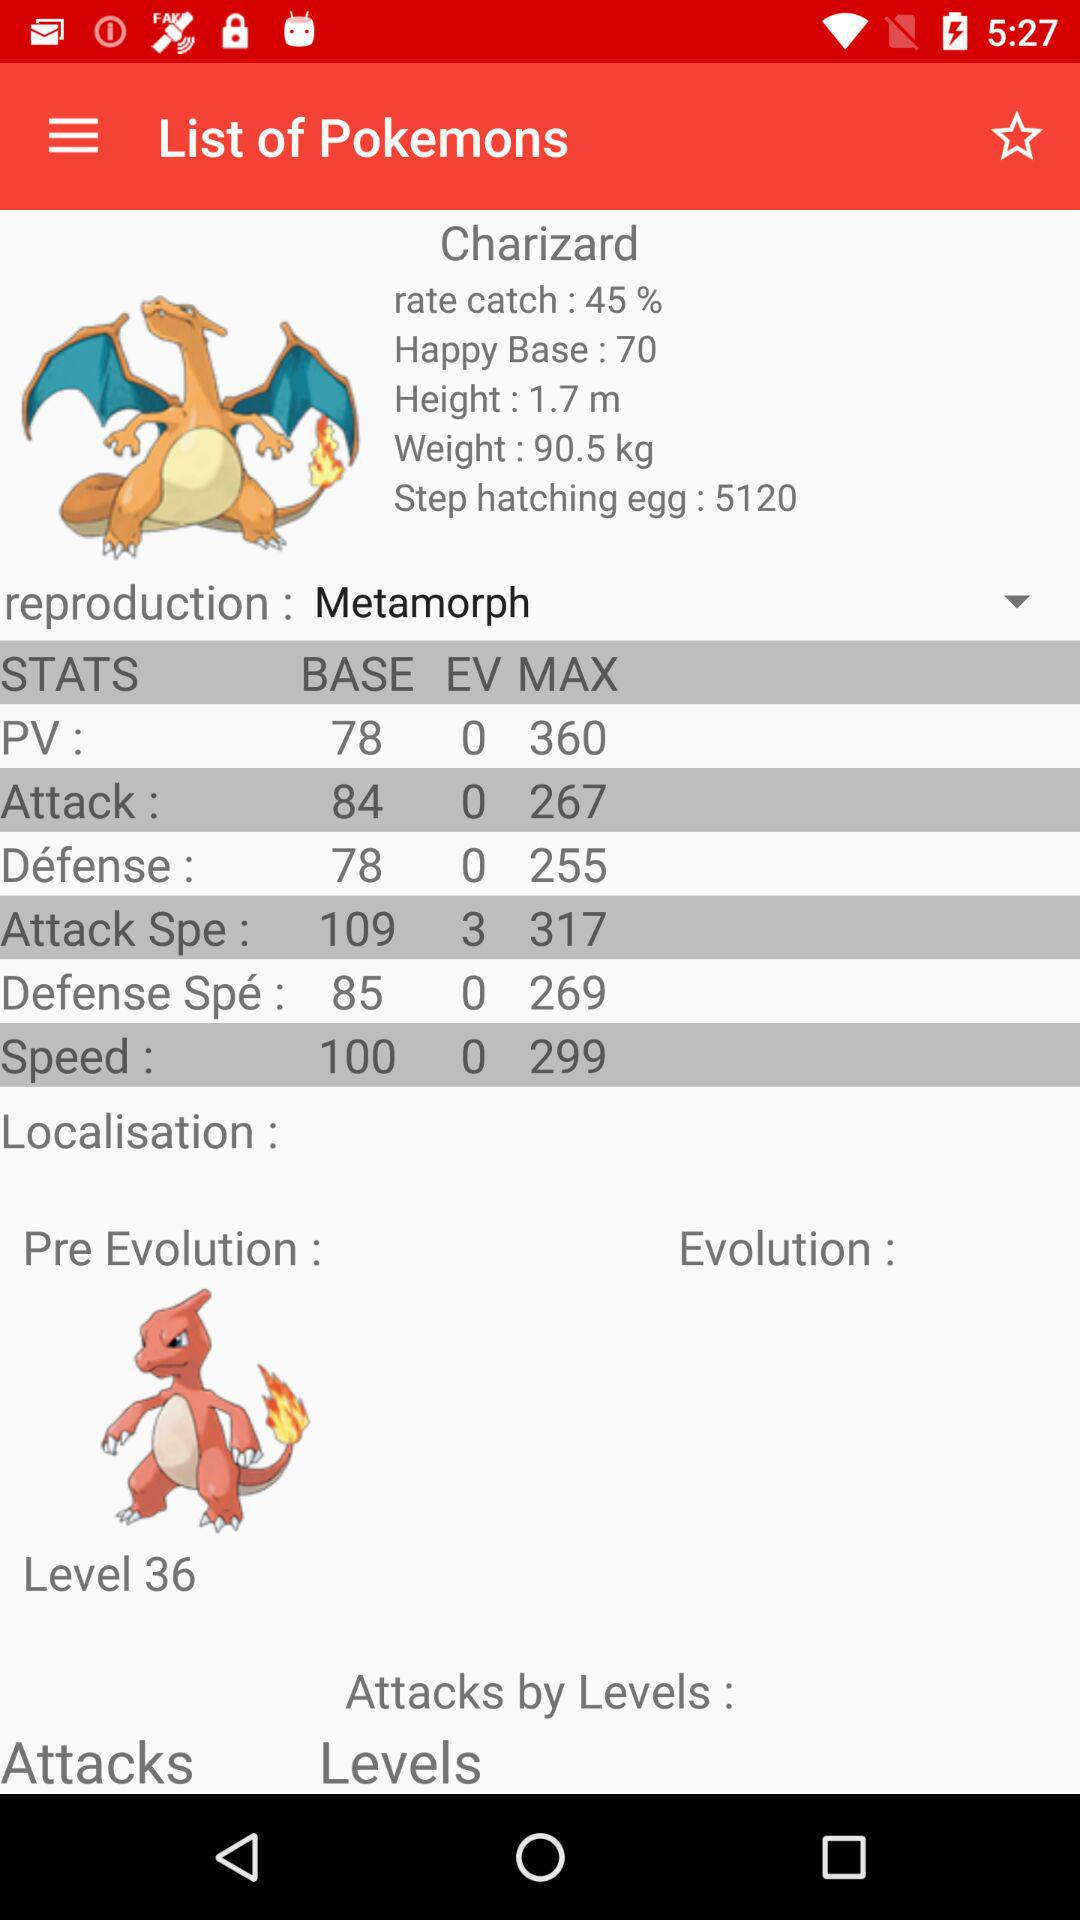What is the level? The level is 36. 